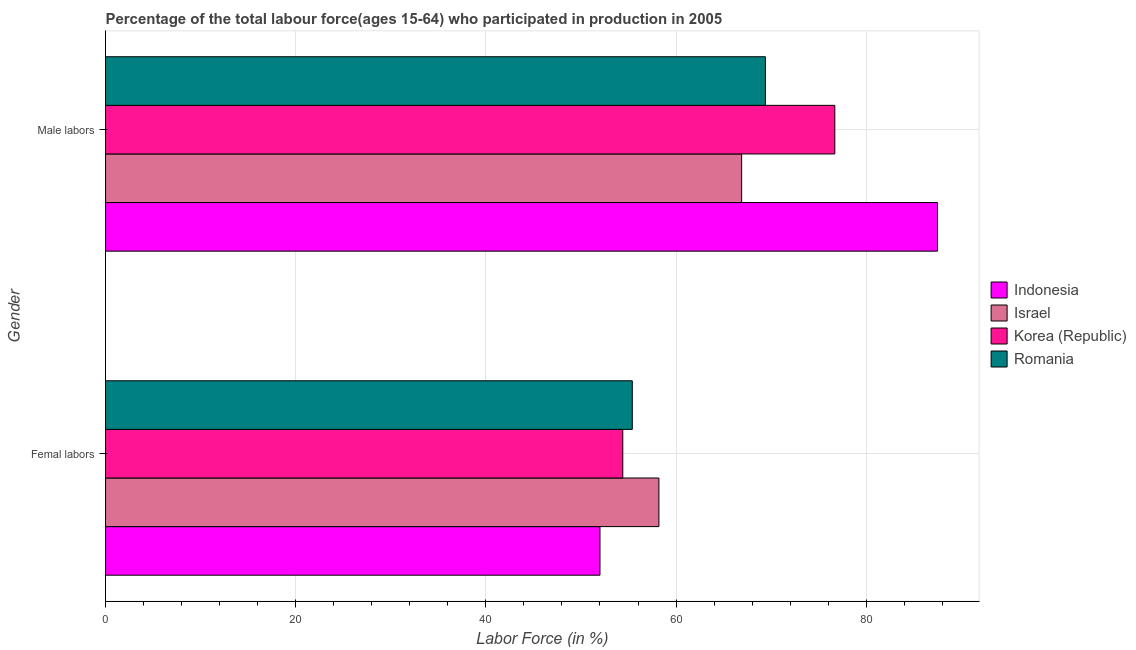How many different coloured bars are there?
Your response must be concise. 4. How many groups of bars are there?
Provide a short and direct response. 2. Are the number of bars per tick equal to the number of legend labels?
Offer a terse response. Yes. Are the number of bars on each tick of the Y-axis equal?
Ensure brevity in your answer.  Yes. How many bars are there on the 1st tick from the top?
Ensure brevity in your answer.  4. What is the label of the 1st group of bars from the top?
Your response must be concise. Male labors. Across all countries, what is the maximum percentage of male labour force?
Ensure brevity in your answer.  87.5. Across all countries, what is the minimum percentage of female labor force?
Ensure brevity in your answer.  52. In which country was the percentage of male labour force maximum?
Offer a terse response. Indonesia. In which country was the percentage of female labor force minimum?
Ensure brevity in your answer.  Indonesia. What is the total percentage of female labor force in the graph?
Make the answer very short. 220. What is the difference between the percentage of male labour force in Korea (Republic) and that in Romania?
Provide a succinct answer. 7.3. What is the difference between the percentage of male labour force in Romania and the percentage of female labor force in Korea (Republic)?
Your response must be concise. 15. What is the average percentage of female labor force per country?
Make the answer very short. 55. What is the difference between the percentage of female labor force and percentage of male labour force in Korea (Republic)?
Make the answer very short. -22.3. What is the ratio of the percentage of female labor force in Indonesia to that in Romania?
Offer a terse response. 0.94. Is the percentage of male labour force in Korea (Republic) less than that in Israel?
Provide a succinct answer. No. What does the 1st bar from the top in Femal labors represents?
Provide a succinct answer. Romania. What does the 4th bar from the bottom in Femal labors represents?
Your response must be concise. Romania. What is the difference between two consecutive major ticks on the X-axis?
Make the answer very short. 20. Are the values on the major ticks of X-axis written in scientific E-notation?
Give a very brief answer. No. Does the graph contain grids?
Give a very brief answer. Yes. Where does the legend appear in the graph?
Provide a succinct answer. Center right. How are the legend labels stacked?
Offer a terse response. Vertical. What is the title of the graph?
Keep it short and to the point. Percentage of the total labour force(ages 15-64) who participated in production in 2005. Does "Barbados" appear as one of the legend labels in the graph?
Your answer should be very brief. No. What is the label or title of the X-axis?
Ensure brevity in your answer.  Labor Force (in %). What is the label or title of the Y-axis?
Give a very brief answer. Gender. What is the Labor Force (in %) in Israel in Femal labors?
Your answer should be very brief. 58.2. What is the Labor Force (in %) in Korea (Republic) in Femal labors?
Make the answer very short. 54.4. What is the Labor Force (in %) of Romania in Femal labors?
Keep it short and to the point. 55.4. What is the Labor Force (in %) of Indonesia in Male labors?
Provide a succinct answer. 87.5. What is the Labor Force (in %) in Israel in Male labors?
Offer a very short reply. 66.9. What is the Labor Force (in %) of Korea (Republic) in Male labors?
Your answer should be compact. 76.7. What is the Labor Force (in %) in Romania in Male labors?
Your response must be concise. 69.4. Across all Gender, what is the maximum Labor Force (in %) in Indonesia?
Provide a short and direct response. 87.5. Across all Gender, what is the maximum Labor Force (in %) of Israel?
Keep it short and to the point. 66.9. Across all Gender, what is the maximum Labor Force (in %) of Korea (Republic)?
Ensure brevity in your answer.  76.7. Across all Gender, what is the maximum Labor Force (in %) in Romania?
Provide a short and direct response. 69.4. Across all Gender, what is the minimum Labor Force (in %) in Indonesia?
Provide a succinct answer. 52. Across all Gender, what is the minimum Labor Force (in %) in Israel?
Provide a short and direct response. 58.2. Across all Gender, what is the minimum Labor Force (in %) in Korea (Republic)?
Offer a very short reply. 54.4. Across all Gender, what is the minimum Labor Force (in %) of Romania?
Offer a very short reply. 55.4. What is the total Labor Force (in %) in Indonesia in the graph?
Ensure brevity in your answer.  139.5. What is the total Labor Force (in %) in Israel in the graph?
Your answer should be very brief. 125.1. What is the total Labor Force (in %) in Korea (Republic) in the graph?
Your answer should be very brief. 131.1. What is the total Labor Force (in %) of Romania in the graph?
Give a very brief answer. 124.8. What is the difference between the Labor Force (in %) of Indonesia in Femal labors and that in Male labors?
Keep it short and to the point. -35.5. What is the difference between the Labor Force (in %) in Israel in Femal labors and that in Male labors?
Offer a terse response. -8.7. What is the difference between the Labor Force (in %) in Korea (Republic) in Femal labors and that in Male labors?
Give a very brief answer. -22.3. What is the difference between the Labor Force (in %) of Romania in Femal labors and that in Male labors?
Provide a short and direct response. -14. What is the difference between the Labor Force (in %) of Indonesia in Femal labors and the Labor Force (in %) of Israel in Male labors?
Offer a terse response. -14.9. What is the difference between the Labor Force (in %) in Indonesia in Femal labors and the Labor Force (in %) in Korea (Republic) in Male labors?
Your answer should be compact. -24.7. What is the difference between the Labor Force (in %) of Indonesia in Femal labors and the Labor Force (in %) of Romania in Male labors?
Give a very brief answer. -17.4. What is the difference between the Labor Force (in %) in Israel in Femal labors and the Labor Force (in %) in Korea (Republic) in Male labors?
Offer a terse response. -18.5. What is the difference between the Labor Force (in %) of Israel in Femal labors and the Labor Force (in %) of Romania in Male labors?
Provide a short and direct response. -11.2. What is the average Labor Force (in %) of Indonesia per Gender?
Give a very brief answer. 69.75. What is the average Labor Force (in %) in Israel per Gender?
Your response must be concise. 62.55. What is the average Labor Force (in %) in Korea (Republic) per Gender?
Make the answer very short. 65.55. What is the average Labor Force (in %) of Romania per Gender?
Ensure brevity in your answer.  62.4. What is the difference between the Labor Force (in %) in Israel and Labor Force (in %) in Korea (Republic) in Femal labors?
Give a very brief answer. 3.8. What is the difference between the Labor Force (in %) in Korea (Republic) and Labor Force (in %) in Romania in Femal labors?
Your response must be concise. -1. What is the difference between the Labor Force (in %) in Indonesia and Labor Force (in %) in Israel in Male labors?
Offer a terse response. 20.6. What is the difference between the Labor Force (in %) in Indonesia and Labor Force (in %) in Korea (Republic) in Male labors?
Make the answer very short. 10.8. What is the difference between the Labor Force (in %) of Israel and Labor Force (in %) of Korea (Republic) in Male labors?
Your answer should be compact. -9.8. What is the difference between the Labor Force (in %) in Israel and Labor Force (in %) in Romania in Male labors?
Ensure brevity in your answer.  -2.5. What is the difference between the Labor Force (in %) in Korea (Republic) and Labor Force (in %) in Romania in Male labors?
Make the answer very short. 7.3. What is the ratio of the Labor Force (in %) in Indonesia in Femal labors to that in Male labors?
Ensure brevity in your answer.  0.59. What is the ratio of the Labor Force (in %) of Israel in Femal labors to that in Male labors?
Keep it short and to the point. 0.87. What is the ratio of the Labor Force (in %) of Korea (Republic) in Femal labors to that in Male labors?
Your response must be concise. 0.71. What is the ratio of the Labor Force (in %) in Romania in Femal labors to that in Male labors?
Your response must be concise. 0.8. What is the difference between the highest and the second highest Labor Force (in %) of Indonesia?
Ensure brevity in your answer.  35.5. What is the difference between the highest and the second highest Labor Force (in %) of Korea (Republic)?
Give a very brief answer. 22.3. What is the difference between the highest and the lowest Labor Force (in %) of Indonesia?
Keep it short and to the point. 35.5. What is the difference between the highest and the lowest Labor Force (in %) in Israel?
Give a very brief answer. 8.7. What is the difference between the highest and the lowest Labor Force (in %) of Korea (Republic)?
Ensure brevity in your answer.  22.3. What is the difference between the highest and the lowest Labor Force (in %) of Romania?
Provide a succinct answer. 14. 